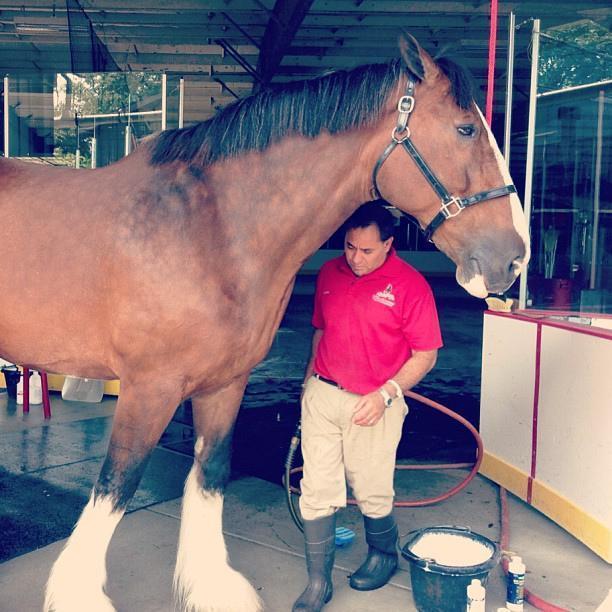How many stacks of bowls are there?
Give a very brief answer. 0. 